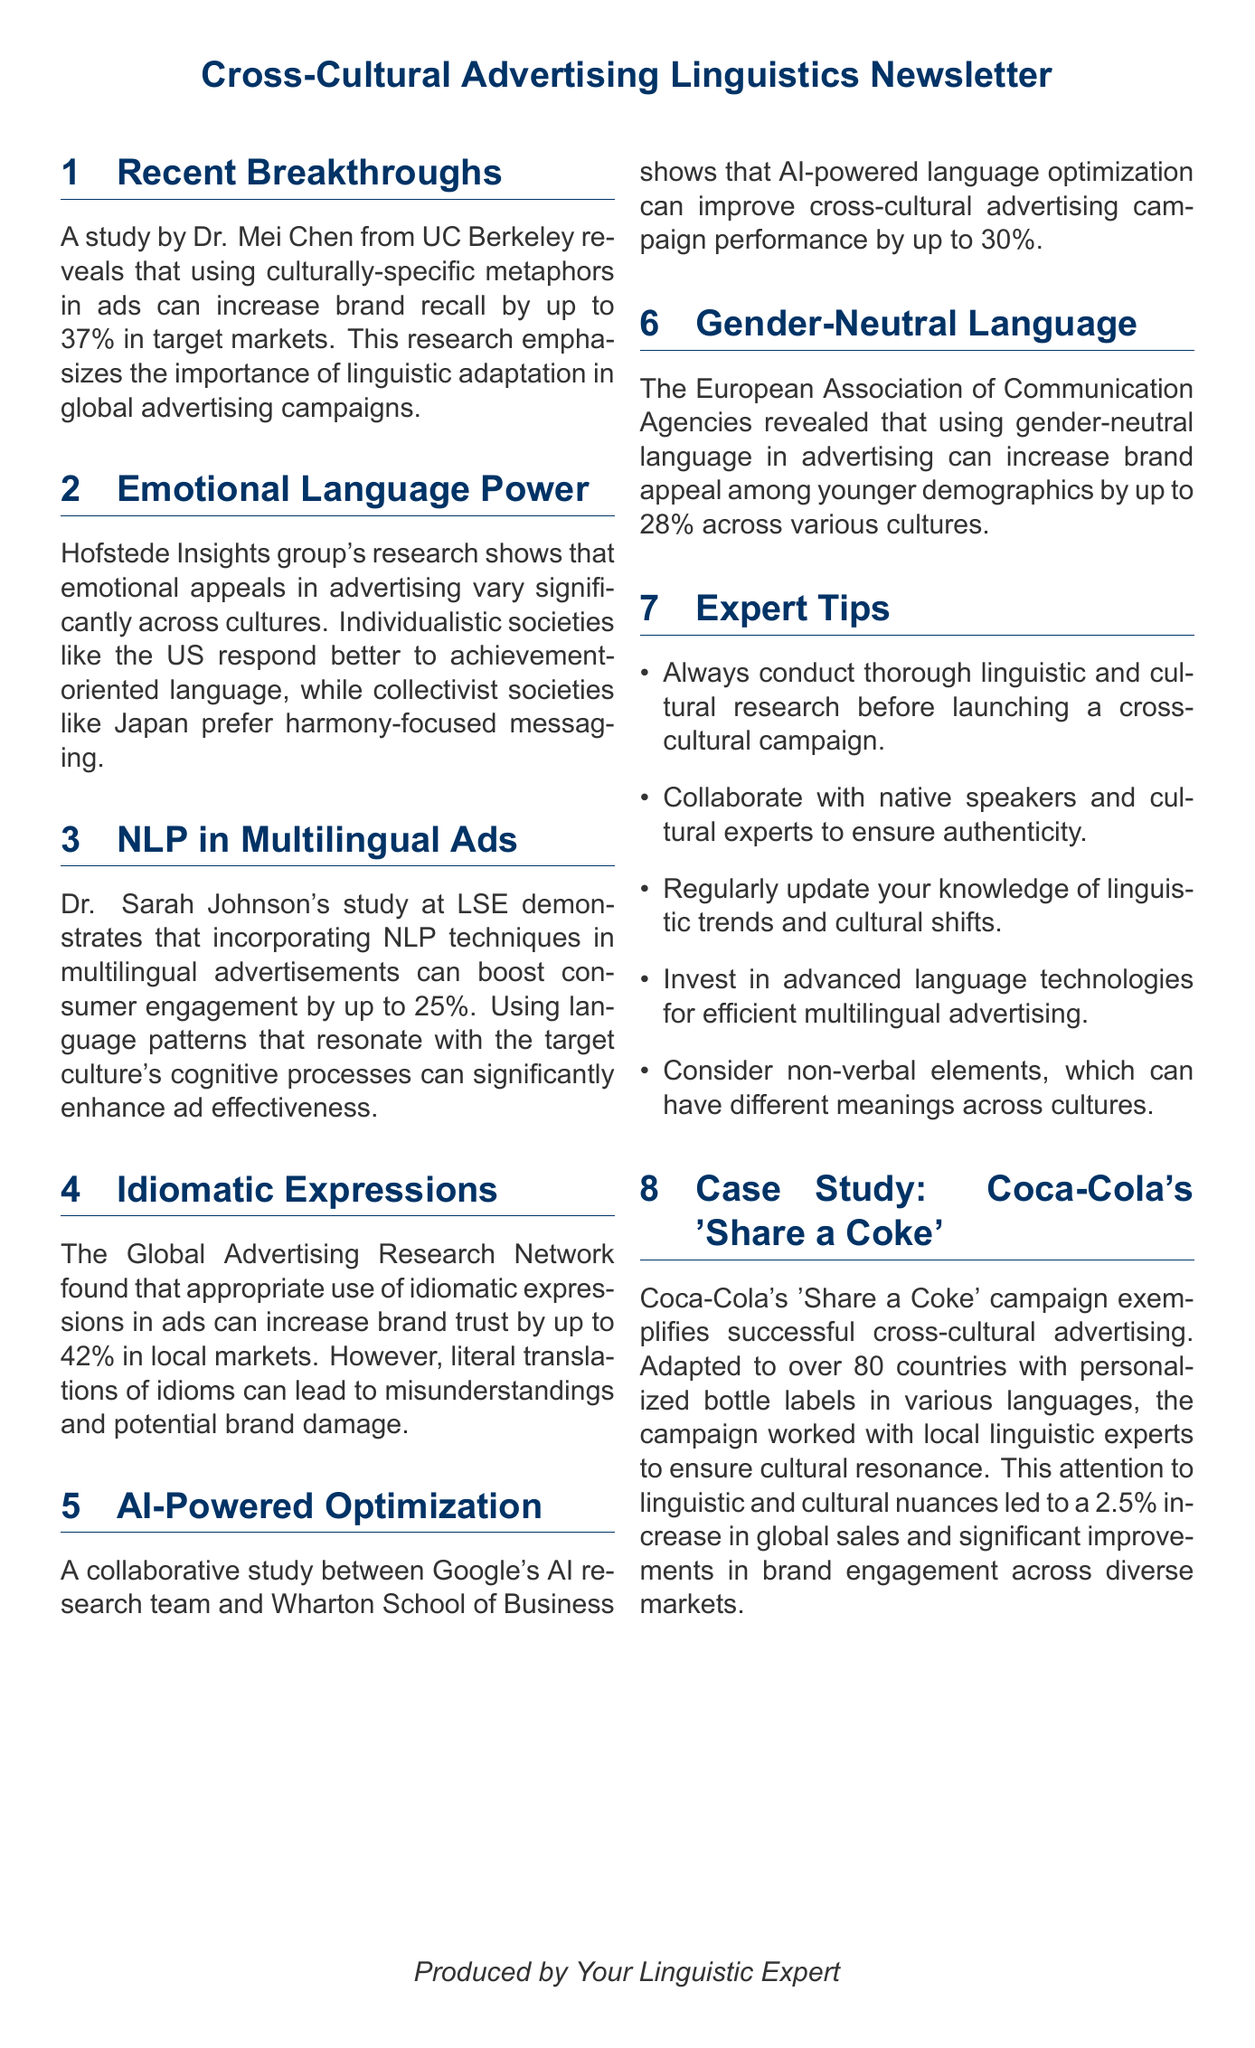What is the percentage increase in brand recall from using culturally-specific metaphors? The study by Dr. Mei Chen states that using culturally-specific metaphors can increase brand recall by up to 37%.
Answer: 37% What society type prefers harmony-focused messaging? The research by the Hofstede Insights group indicates that collectivist societies like Japan prefer harmony-focused messaging.
Answer: Japan Who conducted the NLP study on multilingual advertisements? The groundbreaking study on incorporating NLP techniques was led by Dr. Sarah Johnson at the London School of Economics.
Answer: Dr. Sarah Johnson What is the percentage increase in brand trust from using idiomatic expressions appropriately? The Global Advertising Research Network found that appropriate use of idiomatic expressions can increase brand trust by up to 42%.
Answer: 42% What does EACA stand for? The comprehensive study was conducted by the European Association of Communication Agencies.
Answer: EACA What was the result of Coca-Cola's 'Share a Coke' campaign? The campaign contributed to a 2.5% increase in sales globally.
Answer: 2.5% What language feature can increase brand appeal among younger demographics? The use of gender-neutral language can increase brand appeal among younger demographics by up to 28%.
Answer: gender-neutral language What is the primary benefit of AI-powered language optimization? The collaborative study showed that AI-powered language optimization can improve the performance of cross-cultural advertising campaigns by up to 30%.
Answer: 30% What type of language should be used for better cultural resonance? Using language patterns that resonate with the target culture’s cognitive processes significantly enhances ad effectiveness.
Answer: cognitive processes 